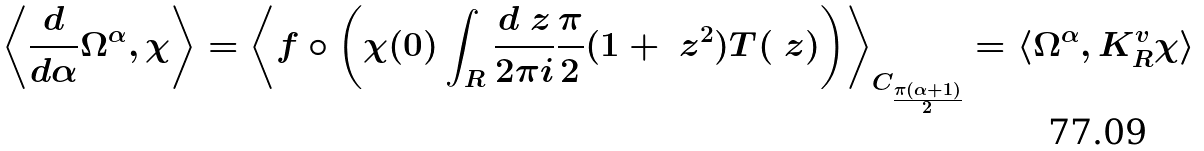Convert formula to latex. <formula><loc_0><loc_0><loc_500><loc_500>\left \langle \frac { d } { d \alpha } \Omega ^ { \alpha } , \chi \right \rangle = \left \langle f \circ \left ( \chi ( 0 ) \int _ { R } \frac { d \ z } { 2 \pi i } \frac { \pi } { 2 } ( 1 + \ z ^ { 2 } ) T ( \ z ) \right ) \right \rangle _ { C _ { \frac { \pi ( \alpha + 1 ) } { 2 } } } = \langle \Omega ^ { \alpha } , K _ { R } ^ { v } \chi \rangle</formula> 